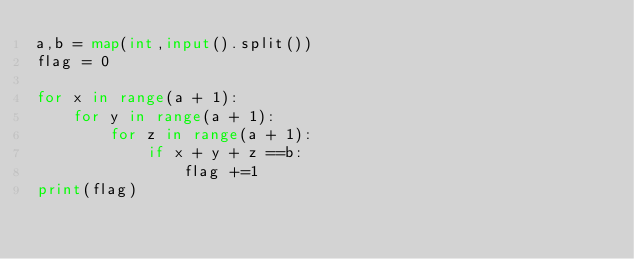Convert code to text. <code><loc_0><loc_0><loc_500><loc_500><_Python_>a,b = map(int,input().split())
flag = 0

for x in range(a + 1):
    for y in range(a + 1):
        for z in range(a + 1):
            if x + y + z ==b:
                flag +=1
print(flag)</code> 